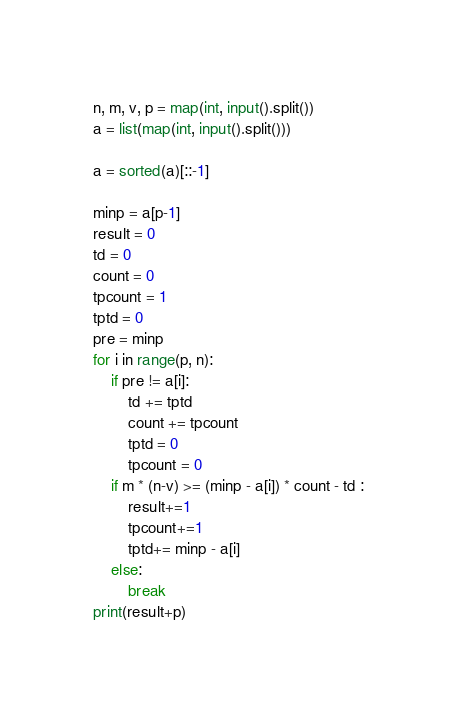<code> <loc_0><loc_0><loc_500><loc_500><_Python_>n, m, v, p = map(int, input().split())
a = list(map(int, input().split()))

a = sorted(a)[::-1]

minp = a[p-1]
result = 0
td = 0
count = 0
tpcount = 1
tptd = 0
pre = minp
for i in range(p, n):
    if pre != a[i]:
        td += tptd
        count += tpcount
        tptd = 0
        tpcount = 0
    if m * (n-v) >= (minp - a[i]) * count - td :
        result+=1
        tpcount+=1
        tptd+= minp - a[i]
    else:
        break
print(result+p)</code> 